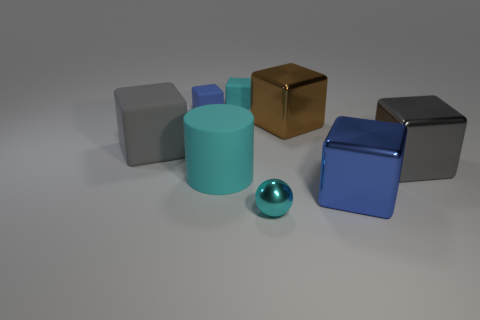There is a large object that is the same color as the large matte cube; what is it made of?
Make the answer very short. Metal. Is the number of small cyan objects greater than the number of big metallic objects?
Ensure brevity in your answer.  No. There is a blue block left of the tiny matte thing that is to the right of the big cyan rubber thing; what is its size?
Your answer should be compact. Small. There is a gray metallic thing that is the same size as the cyan cylinder; what shape is it?
Your response must be concise. Cube. What is the shape of the big thing that is left of the small block that is in front of the tiny rubber thing behind the tiny blue matte object?
Give a very brief answer. Cube. There is a small block that is right of the blue matte object; is its color the same as the cube in front of the rubber cylinder?
Make the answer very short. No. How many gray rubber cubes are there?
Ensure brevity in your answer.  1. Are there any matte objects in front of the tiny blue rubber thing?
Your answer should be very brief. Yes. Does the blue thing that is on the left side of the small metallic thing have the same material as the blue block in front of the brown cube?
Provide a succinct answer. No. Is the number of blue metallic objects that are in front of the blue shiny object less than the number of tiny metal things?
Your answer should be very brief. Yes. 